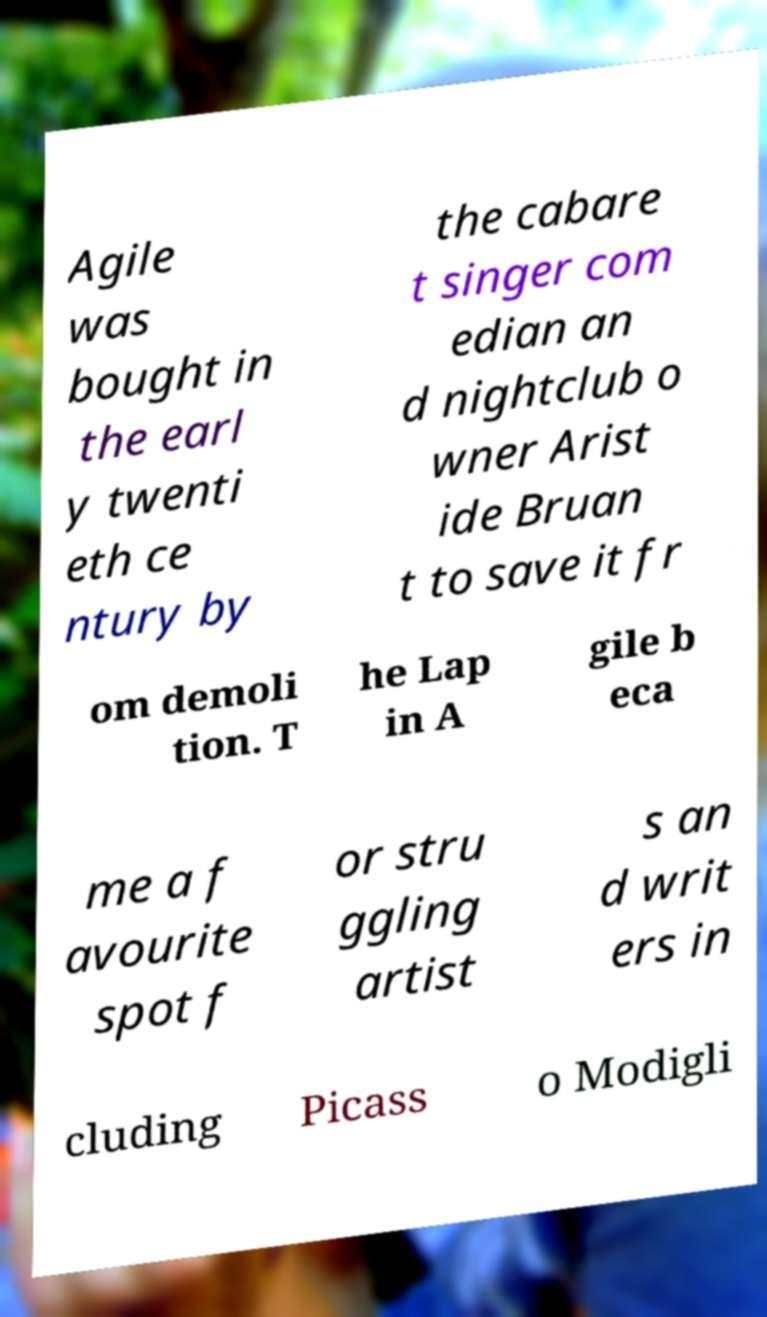There's text embedded in this image that I need extracted. Can you transcribe it verbatim? Agile was bought in the earl y twenti eth ce ntury by the cabare t singer com edian an d nightclub o wner Arist ide Bruan t to save it fr om demoli tion. T he Lap in A gile b eca me a f avourite spot f or stru ggling artist s an d writ ers in cluding Picass o Modigli 